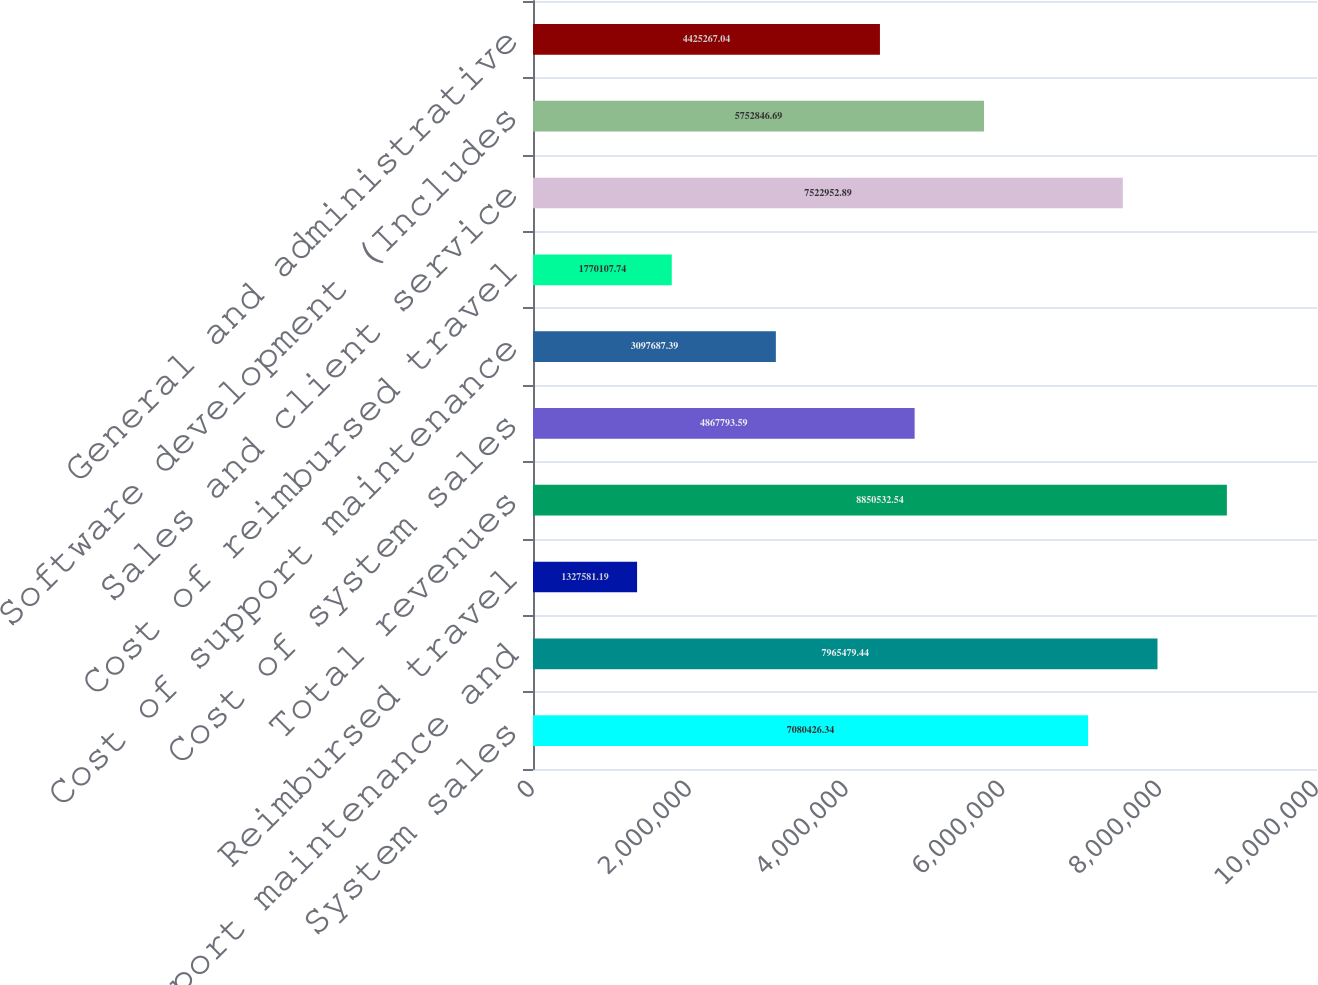<chart> <loc_0><loc_0><loc_500><loc_500><bar_chart><fcel>System sales<fcel>Support maintenance and<fcel>Reimbursed travel<fcel>Total revenues<fcel>Cost of system sales<fcel>Cost of support maintenance<fcel>Cost of reimbursed travel<fcel>Sales and client service<fcel>Software development (Includes<fcel>General and administrative<nl><fcel>7.08043e+06<fcel>7.96548e+06<fcel>1.32758e+06<fcel>8.85053e+06<fcel>4.86779e+06<fcel>3.09769e+06<fcel>1.77011e+06<fcel>7.52295e+06<fcel>5.75285e+06<fcel>4.42527e+06<nl></chart> 